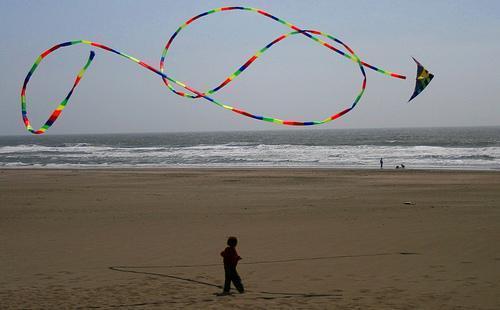How many kites are visible?
Give a very brief answer. 1. 